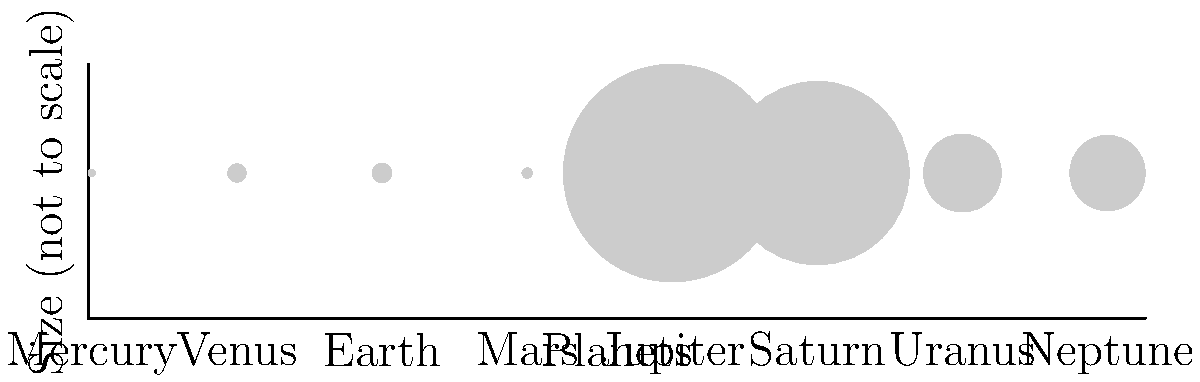As someone who has dedicated their life to promoting human rights, you understand the importance of perspective. In our solar system, the relative sizes of planets offer a similar lesson in perspective. Based on the diagram showing the comparative sizes of planets (not to scale), which planet stands out as significantly larger than the others, and how might this parallel the way certain human rights issues can overshadow others in global discussions? To answer this question, let's analyze the diagram step-by-step:

1. The diagram shows eight circles representing the planets in our solar system, from left to right: Mercury, Venus, Earth, Mars, Jupiter, Saturn, Uranus, and Neptune.

2. The sizes of the circles are proportional to the diameters of the planets, although not drawn to scale.

3. Examining the circles, we can clearly see that Jupiter's circle is significantly larger than all the others.

4. Jupiter's actual diameter is 142,984 km, which is more than 11 times larger than Earth's diameter of 12,756 km.

5. This vast difference in size is represented by the much larger circle for Jupiter compared to the other planets.

Relating this to human rights:
- Just as Jupiter's size dominates the visual representation of our solar system, certain human rights issues can dominate global discussions and media attention.
- However, it's crucial to remember that smaller issues, represented by the smaller planets, are still significant and deserve attention.
- The challenge in human rights advocacy, much like in understanding our solar system, is to maintain perspective and give appropriate attention to all issues, regardless of their perceived "size" in public discourse.
Answer: Jupiter; it parallels how major human rights issues can overshadow smaller but equally important concerns. 